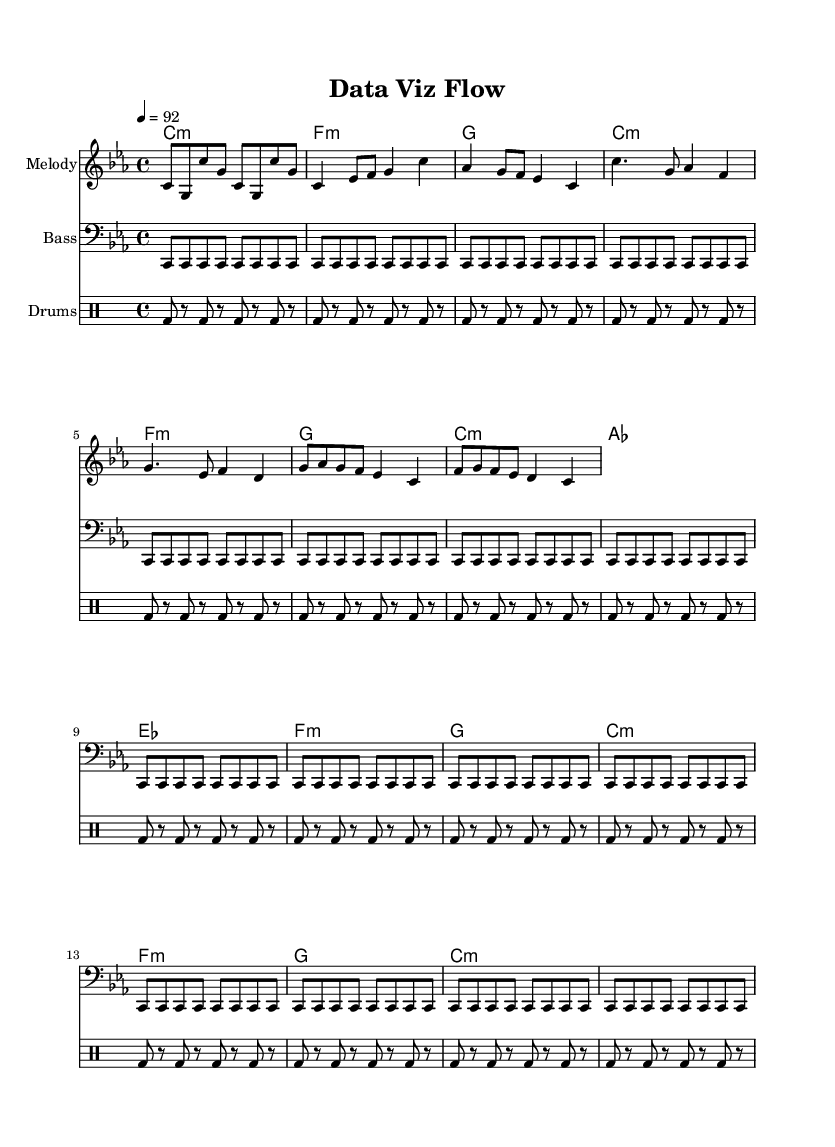What is the key signature of this music? The key signature indicated is C minor, which has three flats (B♭, E♭, and A♭) or can be identified by the 'c' notation in the header section.
Answer: C minor What is the time signature of this music? The time signature is indicated as 4/4, which means there are four beats in each measure and the quarter note gets one beat. This can be seen in the global section of the score.
Answer: 4/4 What is the tempo marking of the piece? The tempo marking is set to 92 beats per minute, indicated in the global section with "4 = 92," which describes how many quarter notes occur in a minute.
Answer: 92 How many measures are in the verse section? The verse section includes four measures, as seen in the melody and harmonies where there are distinct groupings that each represent a measure.
Answer: 4 What type of musical form does this rap song exhibit? The overall structure follows a verse-chorus-bridge pattern, common in many genres, with clear sections that alternate throughout the piece, but particularly noticeable from the melody section as it clearly delineates those parts.
Answer: Verse-chorus-bridge Which instrument is primarily carrying the melody? The melody is primarily carried by the staff labeled "Melody," which is typical for rap songs to have a vocal line represented in instruments within the sheet music, showing a melodic structure.
Answer: Melody What rhythmic pattern is used in the drum section? The drum pattern consists of a repeated bass drum rhythm, where the bass drum occurs on beats and is shown in the drummode section of the score, indicating a simple, consistent beat used in many rap songs.
Answer: BD 